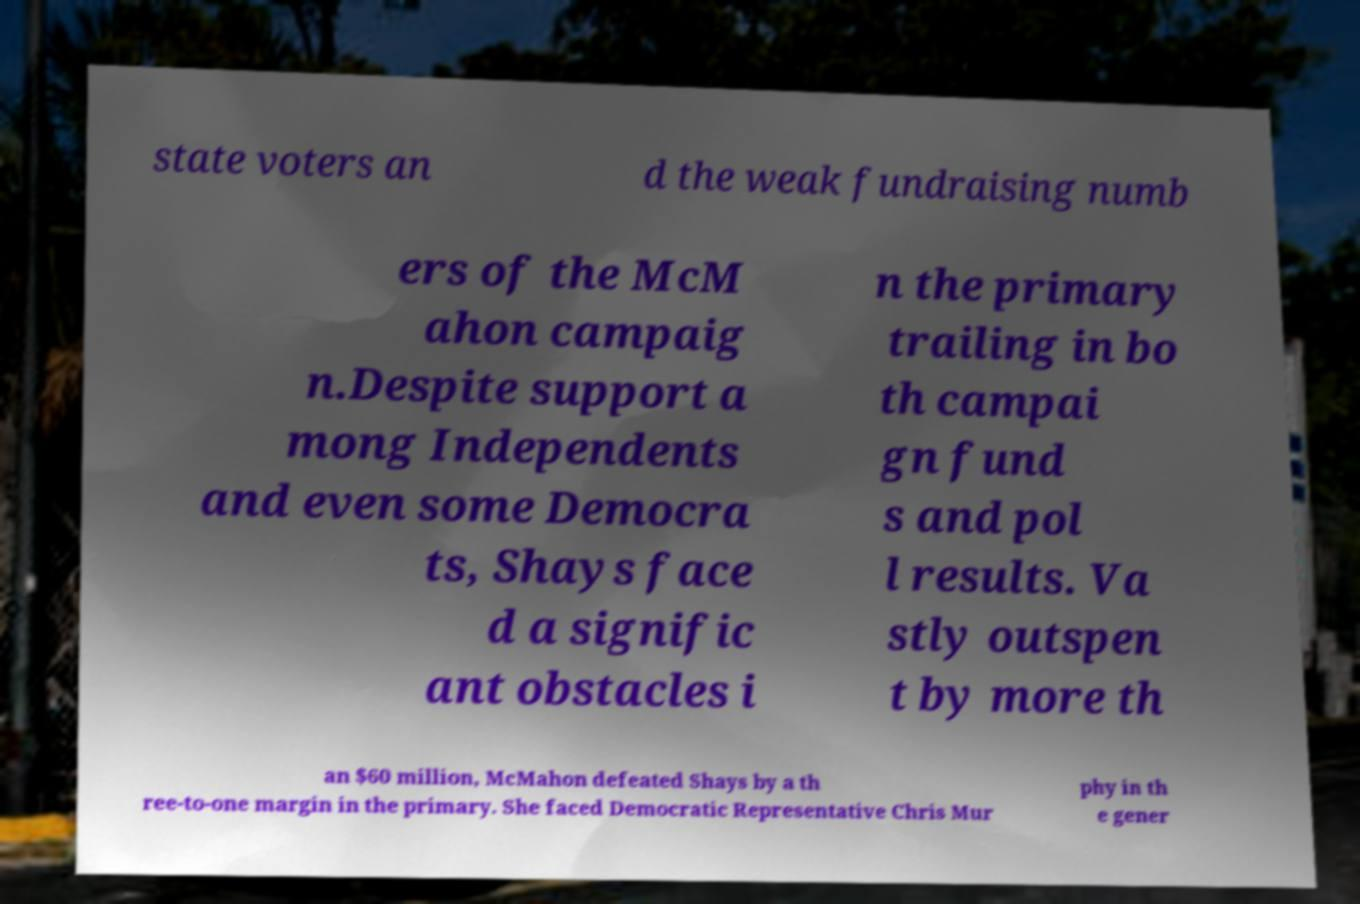Please read and relay the text visible in this image. What does it say? state voters an d the weak fundraising numb ers of the McM ahon campaig n.Despite support a mong Independents and even some Democra ts, Shays face d a signific ant obstacles i n the primary trailing in bo th campai gn fund s and pol l results. Va stly outspen t by more th an $60 million, McMahon defeated Shays by a th ree-to-one margin in the primary. She faced Democratic Representative Chris Mur phy in th e gener 